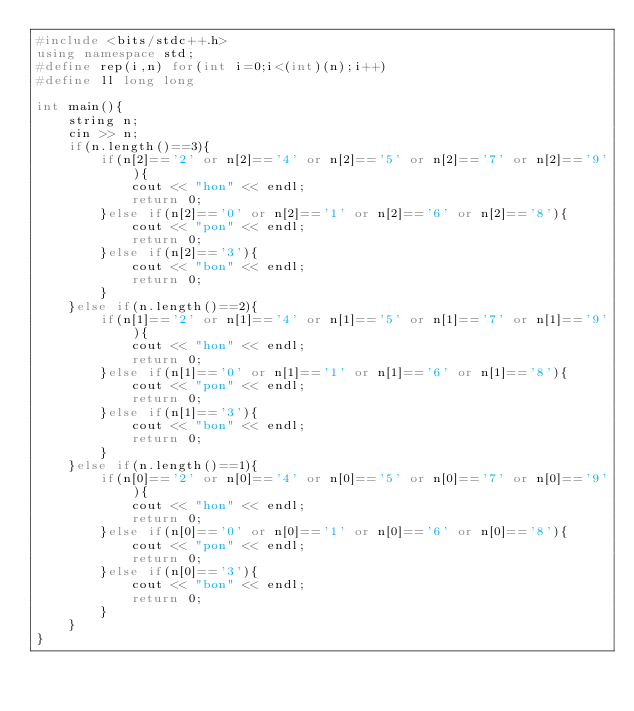Convert code to text. <code><loc_0><loc_0><loc_500><loc_500><_C++_>#include <bits/stdc++.h>
using namespace std;
#define rep(i,n) for(int i=0;i<(int)(n);i++)
#define ll long long

int main(){
    string n;
    cin >> n;
    if(n.length()==3){
        if(n[2]=='2' or n[2]=='4' or n[2]=='5' or n[2]=='7' or n[2]=='9'){
            cout << "hon" << endl;
            return 0;
        }else if(n[2]=='0' or n[2]=='1' or n[2]=='6' or n[2]=='8'){
            cout << "pon" << endl;
            return 0;
        }else if(n[2]=='3'){
            cout << "bon" << endl;
            return 0;
        }
    }else if(n.length()==2){
        if(n[1]=='2' or n[1]=='4' or n[1]=='5' or n[1]=='7' or n[1]=='9'){
            cout << "hon" << endl;
            return 0;
        }else if(n[1]=='0' or n[1]=='1' or n[1]=='6' or n[1]=='8'){
            cout << "pon" << endl;
            return 0;
        }else if(n[1]=='3'){
            cout << "bon" << endl;
            return 0;
        }
    }else if(n.length()==1){
        if(n[0]=='2' or n[0]=='4' or n[0]=='5' or n[0]=='7' or n[0]=='9'){
            cout << "hon" << endl;
            return 0;
        }else if(n[0]=='0' or n[0]=='1' or n[0]=='6' or n[0]=='8'){
            cout << "pon" << endl;
            return 0;
        }else if(n[0]=='3'){
            cout << "bon" << endl;
            return 0;
        }
    }
}</code> 